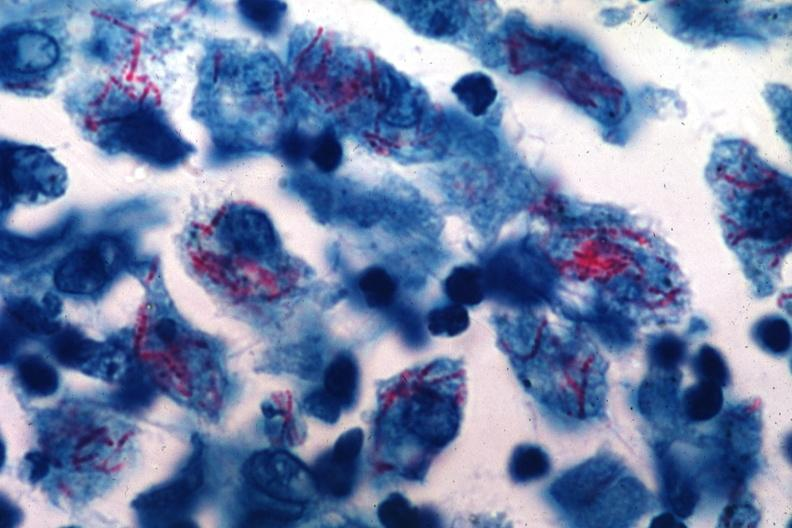what was this of mycobacterium intracellulare infection too many organisms for old time tb?
Answer the question using a single word or phrase. An early case 